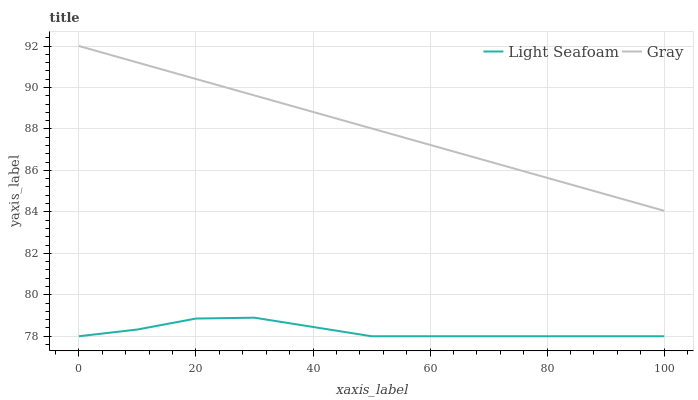Does Light Seafoam have the minimum area under the curve?
Answer yes or no. Yes. Does Gray have the maximum area under the curve?
Answer yes or no. Yes. Does Light Seafoam have the maximum area under the curve?
Answer yes or no. No. Is Gray the smoothest?
Answer yes or no. Yes. Is Light Seafoam the roughest?
Answer yes or no. Yes. Is Light Seafoam the smoothest?
Answer yes or no. No. Does Light Seafoam have the lowest value?
Answer yes or no. Yes. Does Gray have the highest value?
Answer yes or no. Yes. Does Light Seafoam have the highest value?
Answer yes or no. No. Is Light Seafoam less than Gray?
Answer yes or no. Yes. Is Gray greater than Light Seafoam?
Answer yes or no. Yes. Does Light Seafoam intersect Gray?
Answer yes or no. No. 